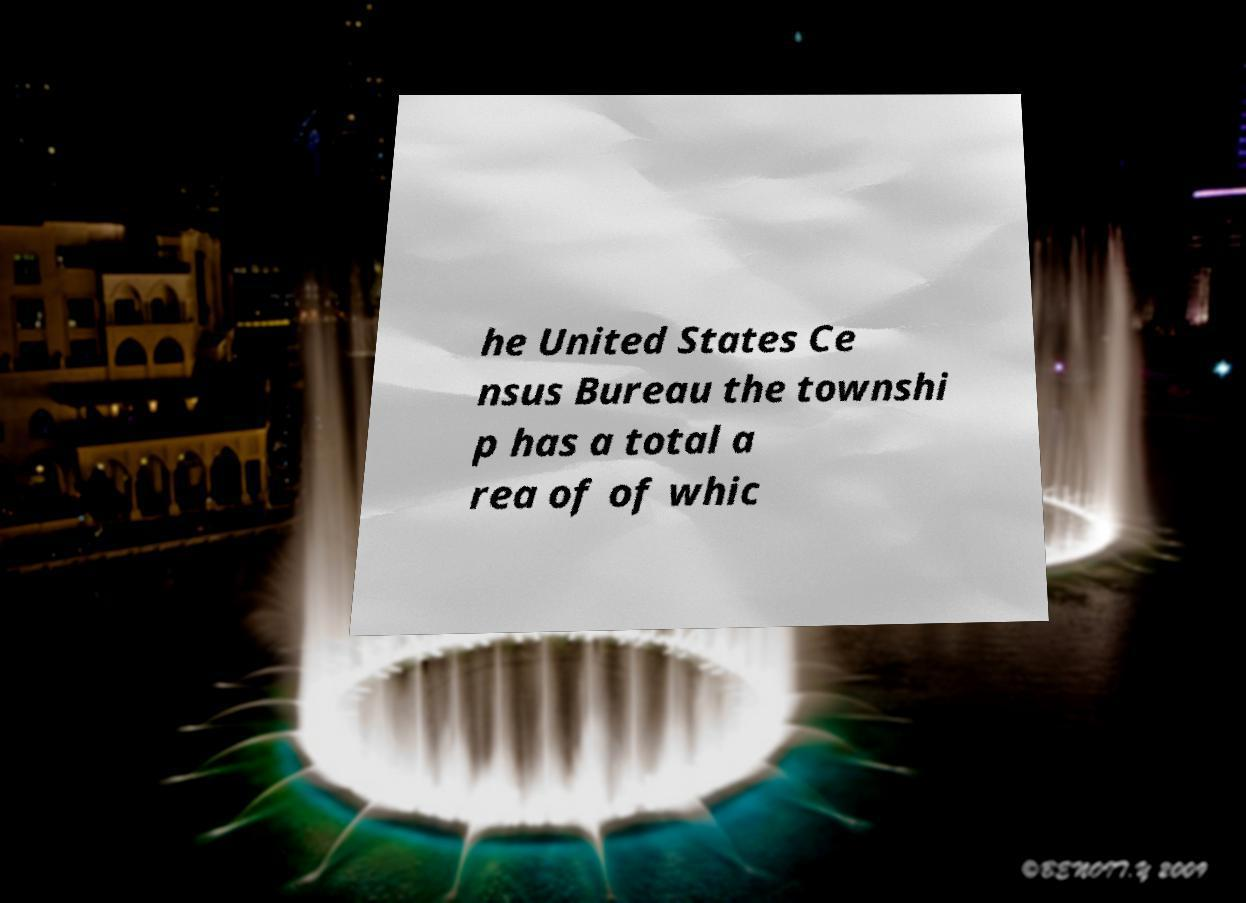Can you accurately transcribe the text from the provided image for me? he United States Ce nsus Bureau the townshi p has a total a rea of of whic 